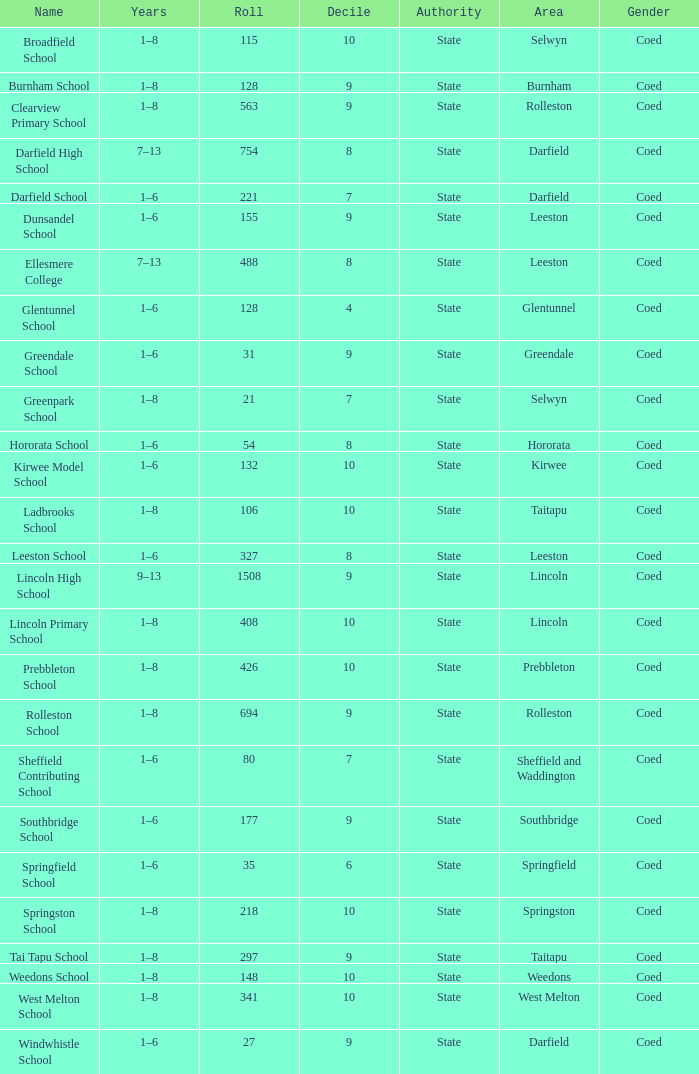What is the total of the roll with a Decile of 8, and an Area of hororata? 54.0. 